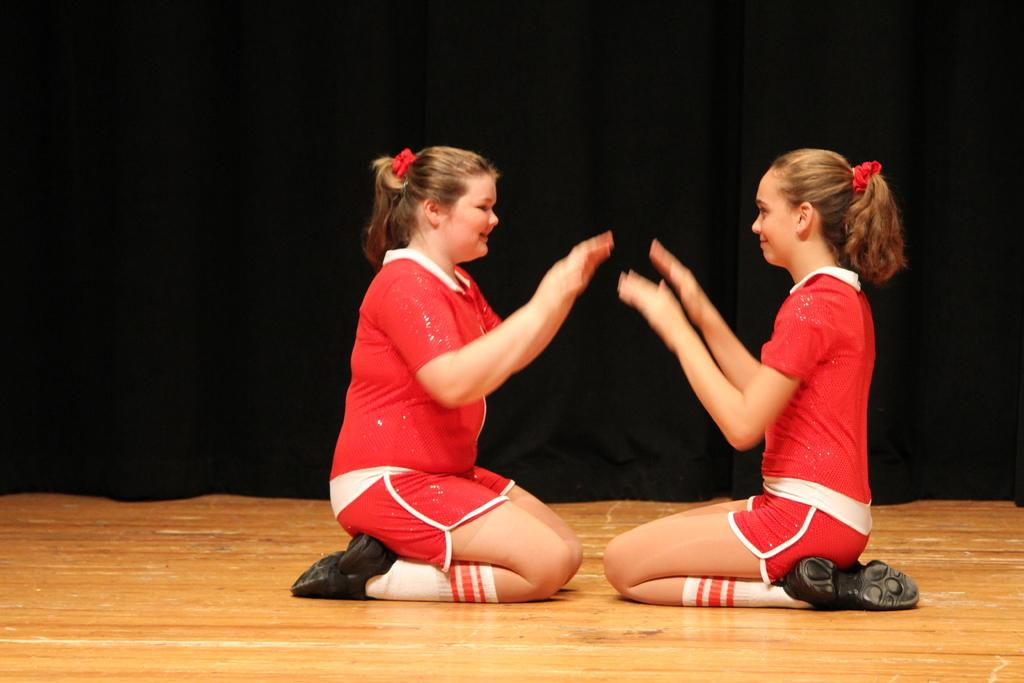How many girls are in the image? There are two girls in the image. What are the girls doing in the image? The girls are sitting on a wooden floor and playing with their hands. What are the girls wearing in the image? Both girls are wearing red dresses. What can be seen behind the girls in the image? There is a black curtain behind the girls. How many pizzas are on the wooden floor in the image? There are no pizzas present in the image; the girls are playing with their hands on the wooden floor. 